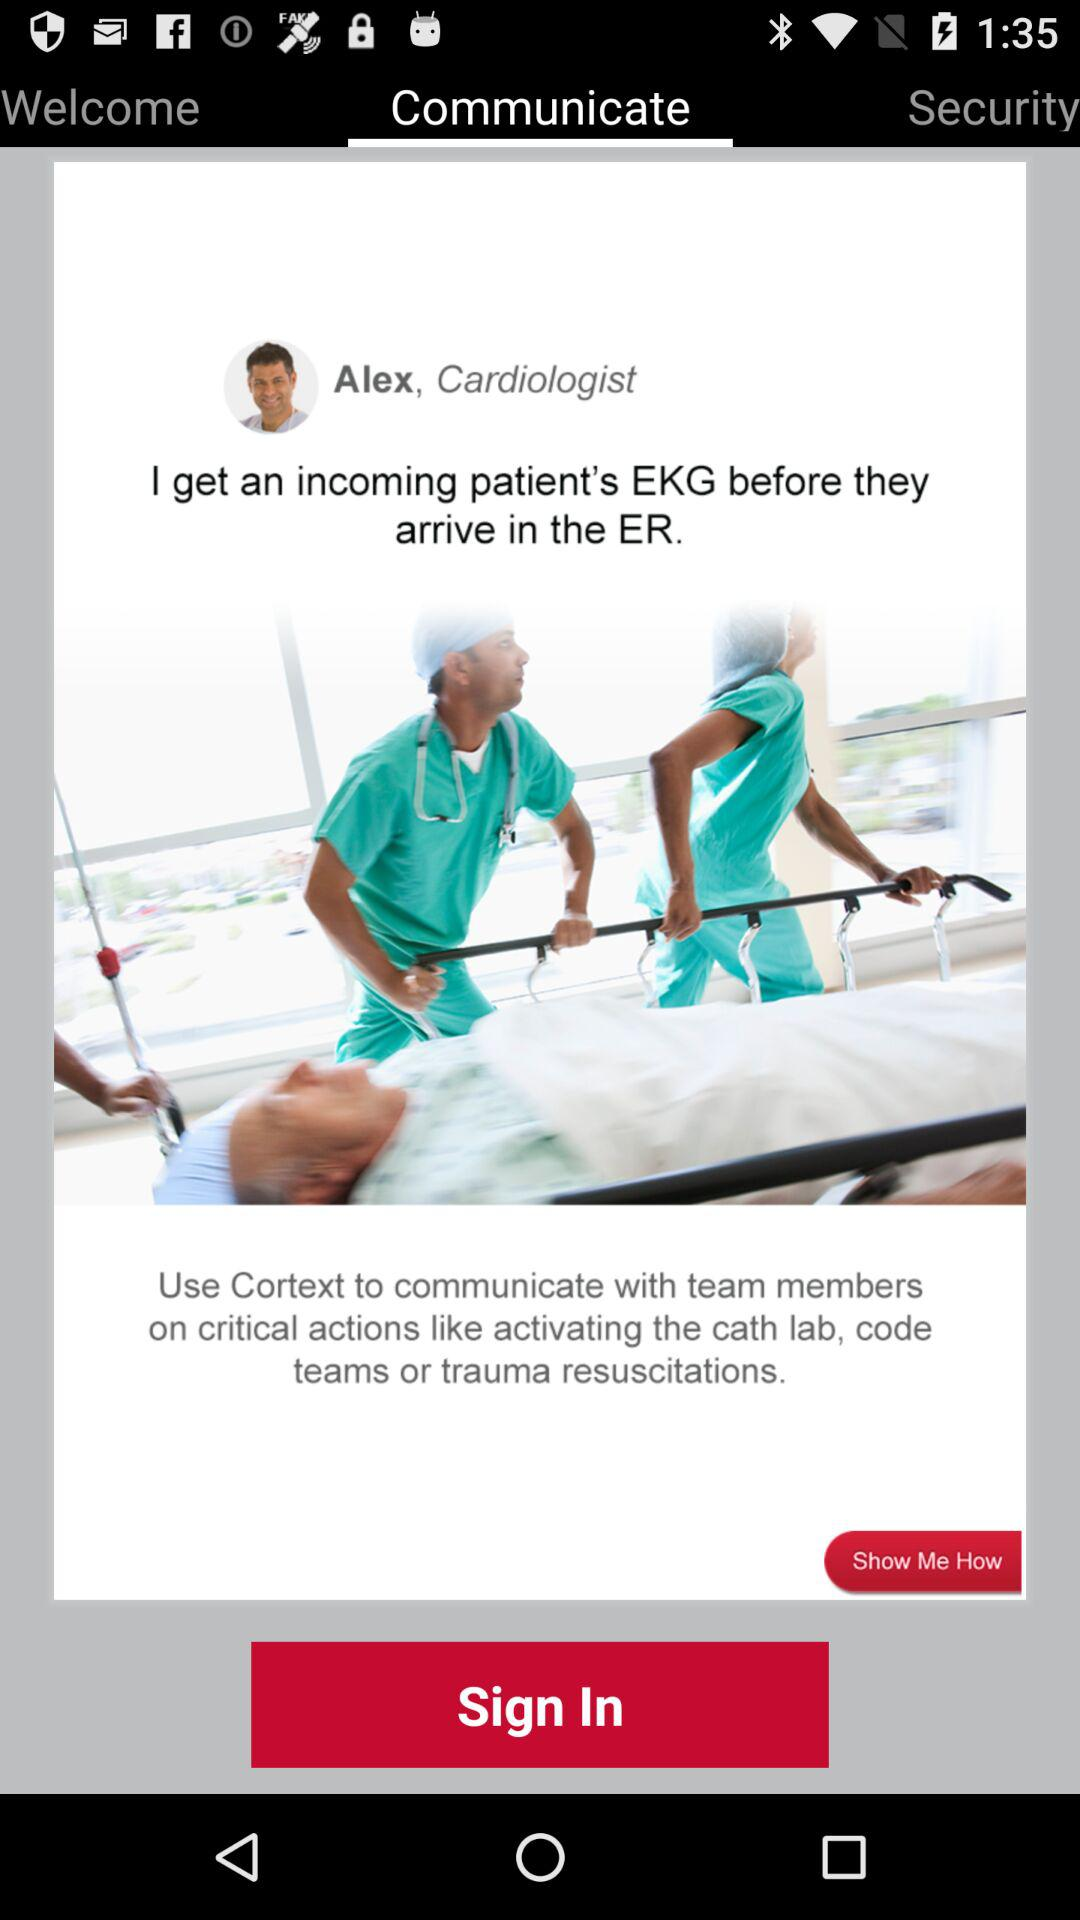Which tab has been selected? The selected tab is "Communicate". 